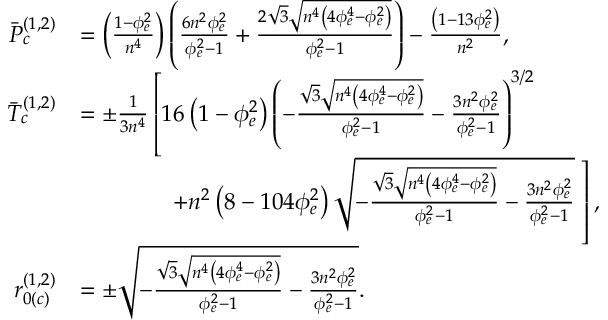Convert formula to latex. <formula><loc_0><loc_0><loc_500><loc_500>\begin{array} { r l } { \ B a r { P } _ { c } ^ { ( 1 , 2 ) } } & { = \left ( \frac { 1 - \phi _ { e } ^ { 2 } } { n ^ { 4 } } \right ) \left ( \frac { 6 n ^ { 2 } \phi _ { e } ^ { 2 } } { \phi _ { e } ^ { 2 } - 1 } + \frac { 2 \sqrt { 3 } \sqrt { n ^ { 4 } \left ( 4 \phi _ { e } ^ { 4 } - \phi _ { e } ^ { 2 } \right ) } } { \phi _ { e } ^ { 2 } - 1 } \right ) - \frac { \left ( 1 - 1 3 \phi _ { e } ^ { 2 } \right ) } { n ^ { 2 } } , } \\ { \ B a r { T } _ { c } ^ { ( 1 , 2 ) } } & { = \pm \frac { 1 } { 3 n ^ { 4 } } \left [ 1 6 \left ( 1 - \phi _ { e } ^ { 2 } \right ) \left ( - \frac { \sqrt { 3 } \sqrt { n ^ { 4 } \left ( 4 \phi _ { e } ^ { 4 } - \phi _ { e } ^ { 2 } \right ) } } { \phi _ { e } ^ { 2 } - 1 } - \frac { 3 n ^ { 2 } \phi _ { e } ^ { 2 } } { \phi _ { e } ^ { 2 } - 1 } \right ) ^ { 3 / 2 } } \\ & { \, + n ^ { 2 } \left ( 8 - 1 0 4 \phi _ { e } ^ { 2 } \right ) \sqrt { - \frac { \sqrt { 3 } \sqrt { n ^ { 4 } \left ( 4 \phi _ { e } ^ { 4 } - \phi _ { e } ^ { 2 } \right ) } } { \phi _ { e } ^ { 2 } - 1 } - \frac { 3 n ^ { 2 } \phi _ { e } ^ { 2 } } { \phi _ { e } ^ { 2 } - 1 } } \, \right ] , } \\ { r _ { 0 ( c ) } ^ { ( 1 , 2 ) } } & { = \pm \sqrt { - \frac { \sqrt { 3 } \sqrt { n ^ { 4 } \left ( 4 \phi _ { e } ^ { 4 } - \phi _ { e } ^ { 2 } \right ) } } { \phi _ { e } ^ { 2 } - 1 } - \frac { 3 n ^ { 2 } \phi _ { e } ^ { 2 } } { \phi _ { e } ^ { 2 } - 1 } } . } \end{array}</formula> 